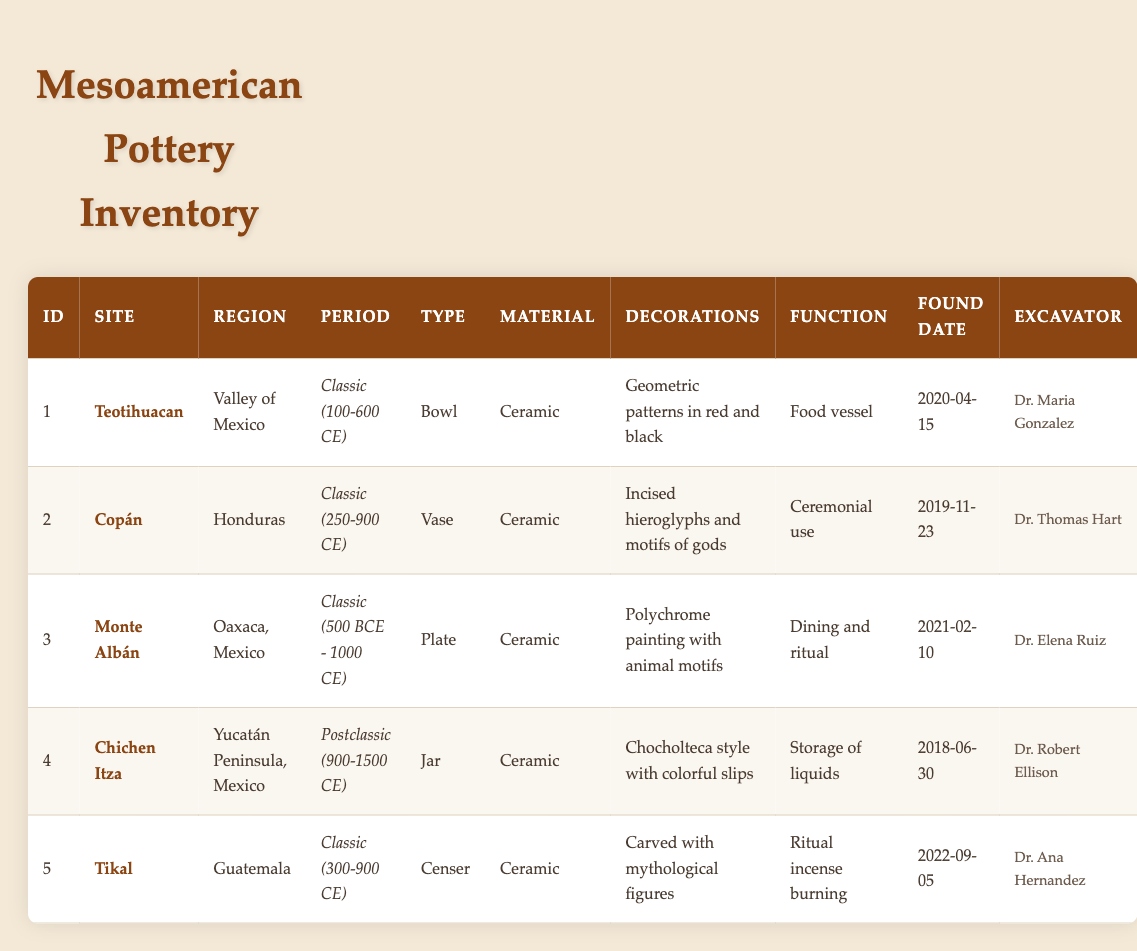What type of pottery was found at Teotihuacan? The table lists the type of pottery found at each site. According to the entry for Teotihuacan, the type is a "Bowl".
Answer: Bowl Which site had pottery with incised hieroglyphs and motifs of gods? Looking at the decorations column, the pottery with "Incised hieroglyphs and motifs of gods" was found at the site called Copán.
Answer: Copán What is the function of the pottery discovered at Chichen Itza? The function of the pottery found at Chichen Itza is detailed in the function column, which indicates it was used for "Storage of liquids".
Answer: Storage of liquids What was the earliest date a pottery item was excavated? By reviewing the found date column, we see that the earliest date is "2018-06-30" for the pottery found at Chichen Itza.
Answer: 2018-06-30 How many of the pottery items were used for ritual purposes? Looking at the function column, there are two instances of pottery used for ritual purposes: the censer from Tikal (ritual incense burning) and the plate from Monte Albán (dining and ritual). Therefore, the count of ritual use is 2.
Answer: 2 Was any pottery excavated in the region of Guatemala? The table indicates that there is pottery found in Guatemala, specifically the censer found at Tikal. Hence, the answer is yes.
Answer: Yes Which excavator discovered the bowl pottery? According to the table, the bowl pottery found at Teotihuacan was excavated by Dr. Maria Gonzalez.
Answer: Dr. Maria Gonzalez How many types of pottery were discovered during the Classic period? Reviewing the period column, we see that there are four items classified under the Classic period: a bowl, vase, plate, and censer. Therefore, the count is 4.
Answer: 4 What is the most recent found date of the pottery items listed? Examining the found date column, the most recent date is "2022-09-05" for the censer found at Tikal.
Answer: 2022-09-05 Which site has ceramic pottery decorated with polychrome painting and animal motifs? The pottery decorated with "Polychrome painting with animal motifs" was found at Monte Albán. This can be confirmed by looking at the decorations column associated with that site.
Answer: Monte Albán 